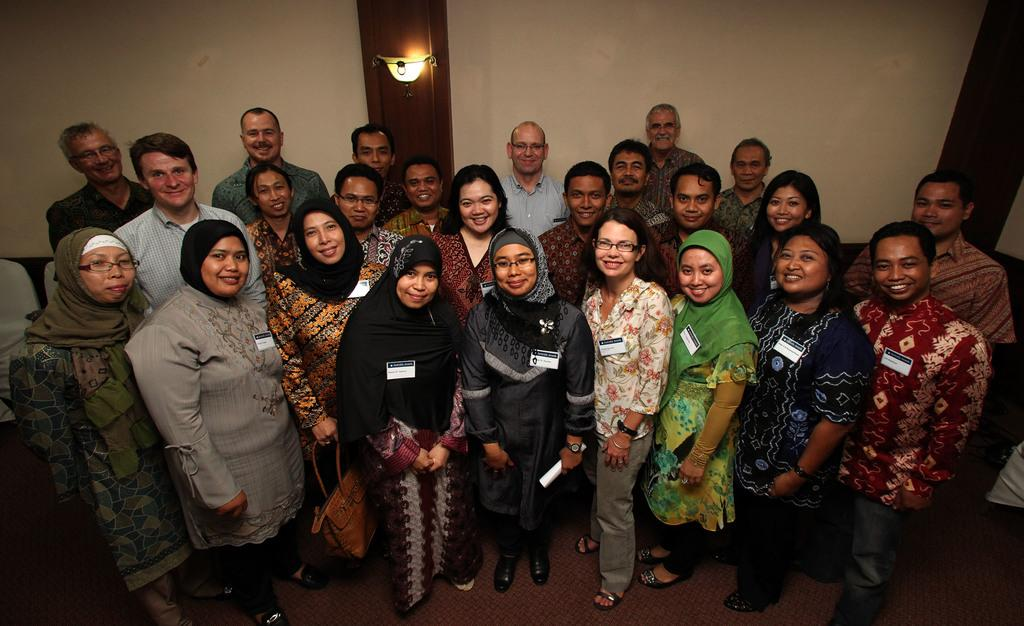How many people are visible in the image? There are many people in the image. What are the people wearing that can be seen in the image? The people are wearing ID cards. What is the surface beneath the people in the image? There is a floor at the bottom of the image. What can be seen in the background of the image? There is a wall and a lamp in the background of the image. How much muscle can be seen on the crook in the image? There is no crook present in the image, and therefore no muscle can be observed. 